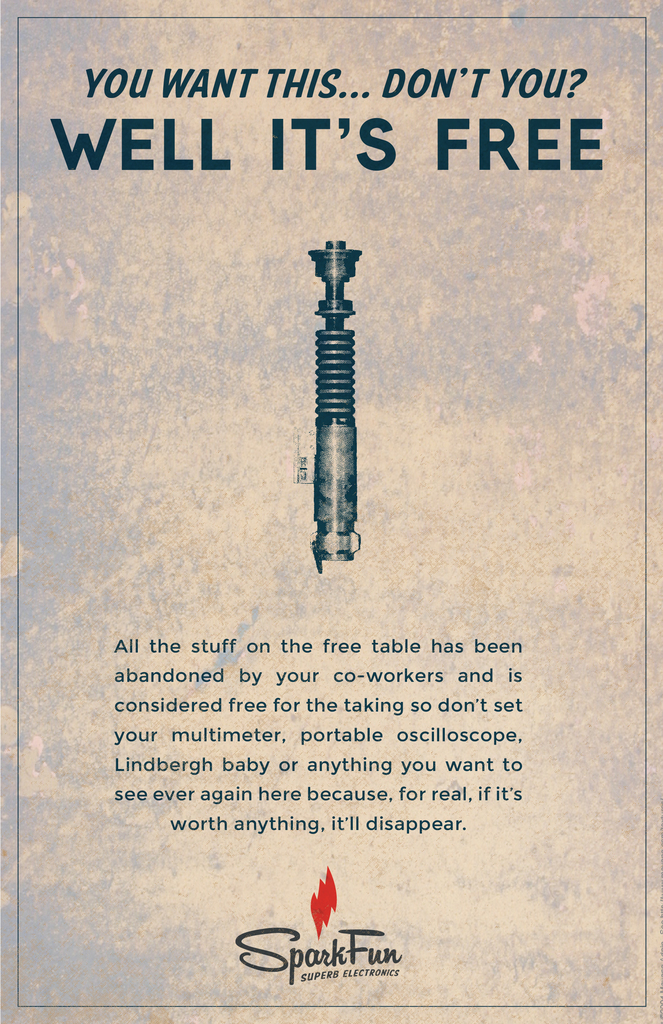What are the key elements in this picture? The image features an advertisement from SparkFun Electronics for a free soldering iron. The text "You want this... don't you? Well it's free" is prominently displayed above the image of the soldering iron, suggesting a direct appeal to the viewer's interest. Further text below the soldering iron explains that the items on this 'free wall' have been abandoned by coworkers and are now available for anyone to take. This implies a culture of sharing and reuse within the organization. 